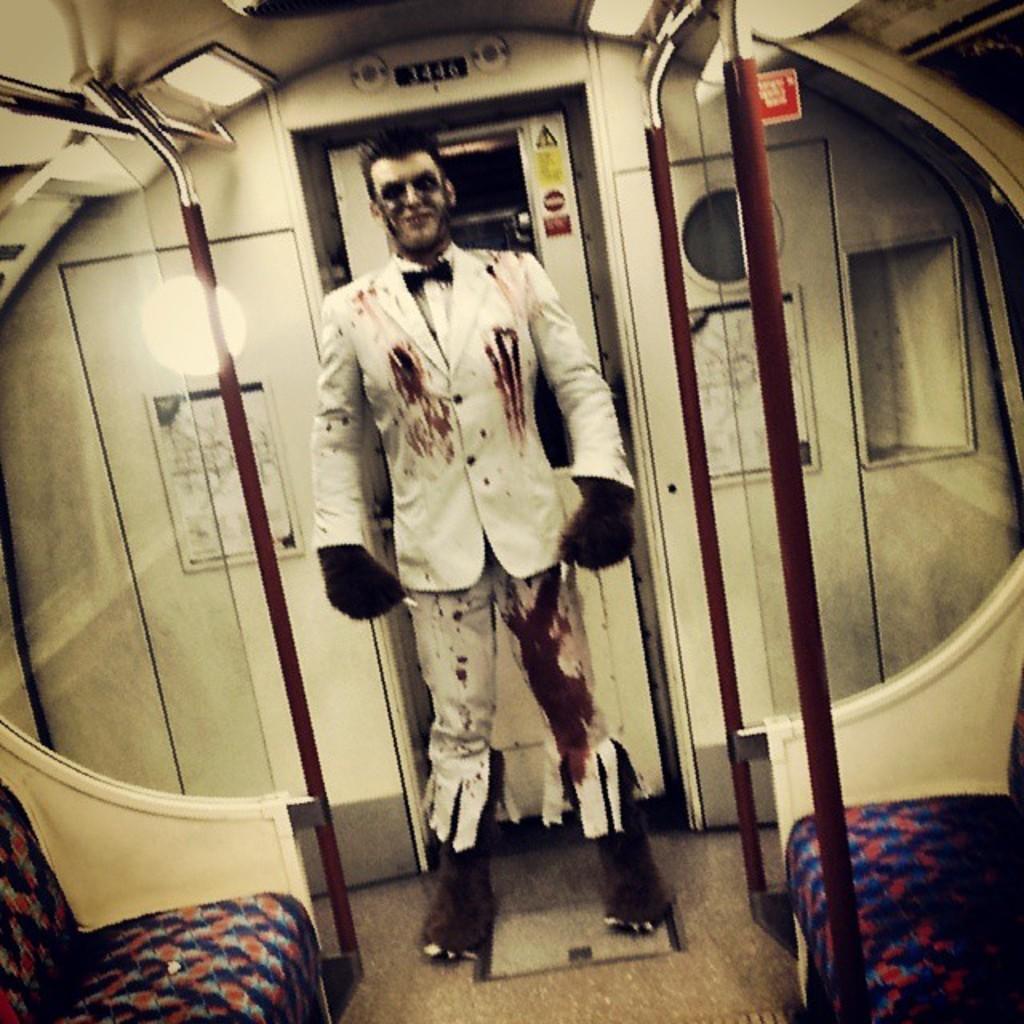Could you give a brief overview of what you see in this image? In this picture I can see there is a man standing and he is wearing a white coat and a pant and there is some blood on pant and coat and there are doors and lights attached to the ceiling. There are polls and seats into right and left. 